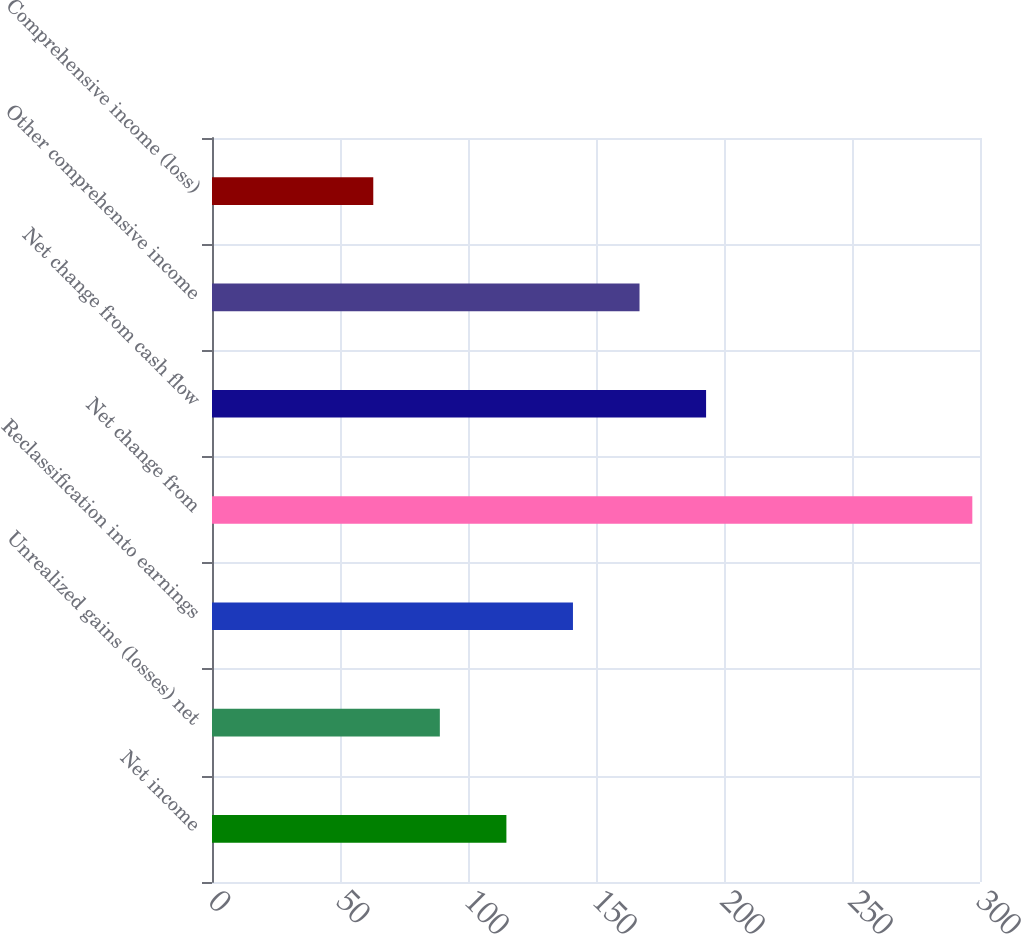Convert chart. <chart><loc_0><loc_0><loc_500><loc_500><bar_chart><fcel>Net income<fcel>Unrealized gains (losses) net<fcel>Reclassification into earnings<fcel>Net change from<fcel>Net change from cash flow<fcel>Other comprehensive income<fcel>Comprehensive income (loss)<nl><fcel>115<fcel>89<fcel>141<fcel>297<fcel>193<fcel>167<fcel>63<nl></chart> 